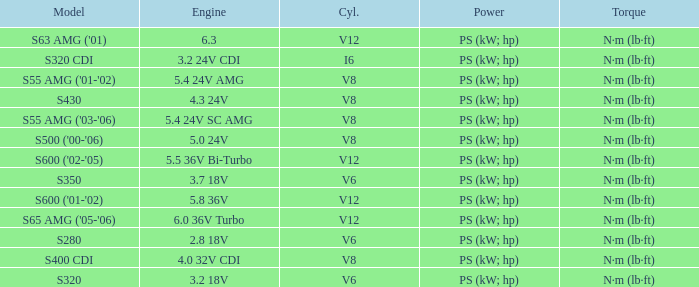Which Torque has a Model of s63 amg ('01)? N·m (lb·ft). 